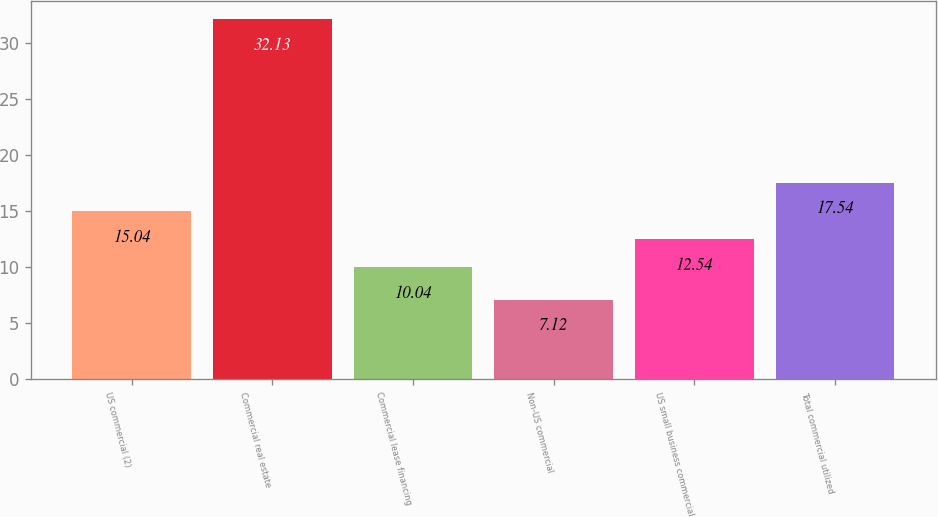Convert chart to OTSL. <chart><loc_0><loc_0><loc_500><loc_500><bar_chart><fcel>US commercial (2)<fcel>Commercial real estate<fcel>Commercial lease financing<fcel>Non-US commercial<fcel>US small business commercial<fcel>Total commercial utilized<nl><fcel>15.04<fcel>32.13<fcel>10.04<fcel>7.12<fcel>12.54<fcel>17.54<nl></chart> 